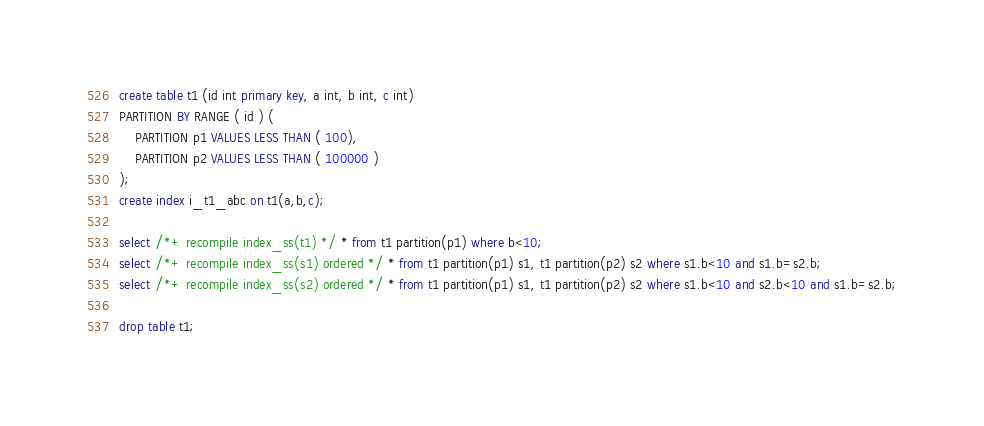Convert code to text. <code><loc_0><loc_0><loc_500><loc_500><_SQL_>create table t1 (id int primary key, a int, b int, c int) 
PARTITION BY RANGE ( id ) (
    PARTITION p1 VALUES LESS THAN ( 100),
    PARTITION p2 VALUES LESS THAN ( 100000 )
);
create index i_t1_abc on t1(a,b,c);

select /*+ recompile index_ss(t1) */ * from t1 partition(p1) where b<10;
select /*+ recompile index_ss(s1) ordered */ * from t1 partition(p1) s1, t1 partition(p2) s2 where s1.b<10 and s1.b=s2.b;
select /*+ recompile index_ss(s2) ordered */ * from t1 partition(p1) s1, t1 partition(p2) s2 where s1.b<10 and s2.b<10 and s1.b=s2.b;

drop table t1;

</code> 